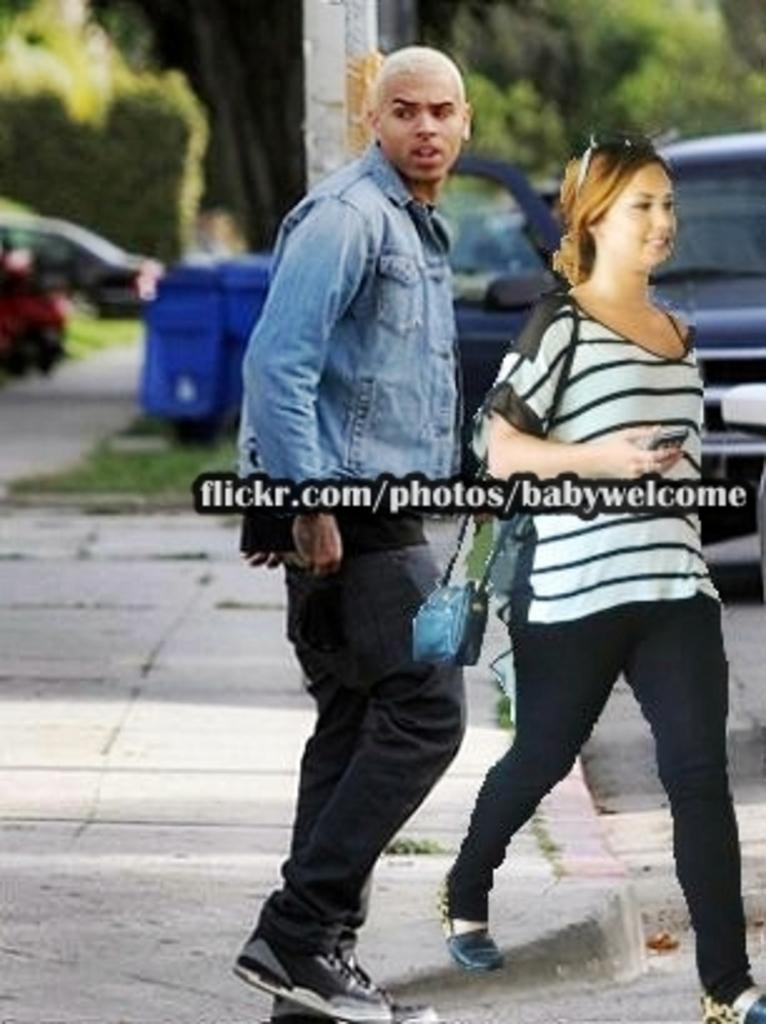<image>
Offer a succinct explanation of the picture presented. The flickr.com website is advertised with man and woman. 